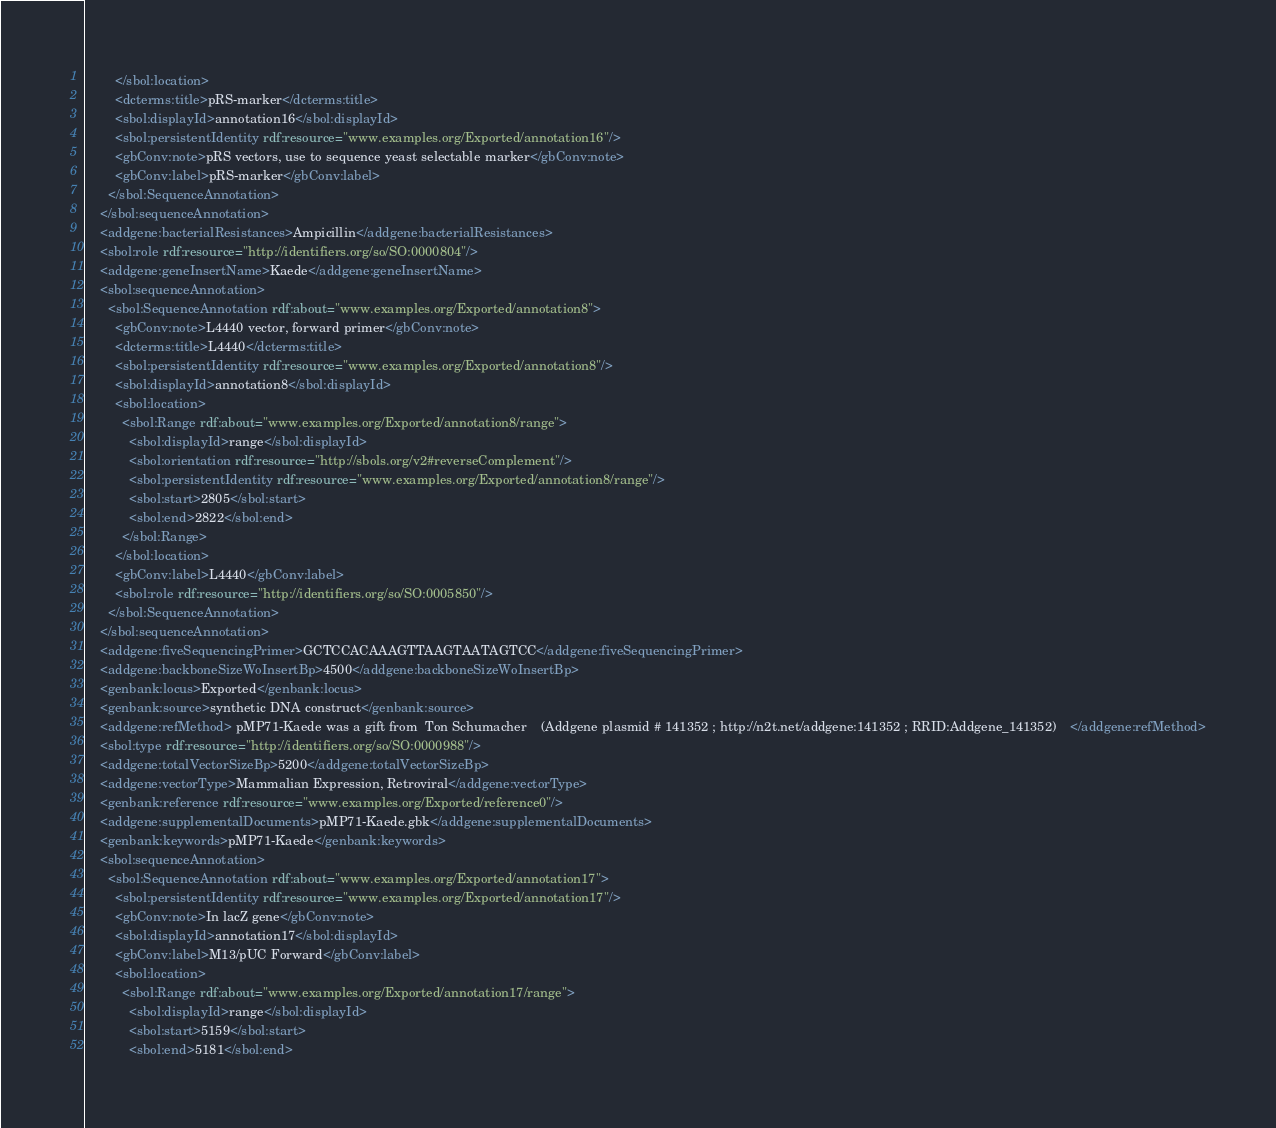<code> <loc_0><loc_0><loc_500><loc_500><_XML_>        </sbol:location>
        <dcterms:title>pRS-marker</dcterms:title>
        <sbol:displayId>annotation16</sbol:displayId>
        <sbol:persistentIdentity rdf:resource="www.examples.org/Exported/annotation16"/>
        <gbConv:note>pRS vectors, use to sequence yeast selectable marker</gbConv:note>
        <gbConv:label>pRS-marker</gbConv:label>
      </sbol:SequenceAnnotation>
    </sbol:sequenceAnnotation>
    <addgene:bacterialResistances>Ampicillin</addgene:bacterialResistances>
    <sbol:role rdf:resource="http://identifiers.org/so/SO:0000804"/>
    <addgene:geneInsertName>Kaede</addgene:geneInsertName>
    <sbol:sequenceAnnotation>
      <sbol:SequenceAnnotation rdf:about="www.examples.org/Exported/annotation8">
        <gbConv:note>L4440 vector, forward primer</gbConv:note>
        <dcterms:title>L4440</dcterms:title>
        <sbol:persistentIdentity rdf:resource="www.examples.org/Exported/annotation8"/>
        <sbol:displayId>annotation8</sbol:displayId>
        <sbol:location>
          <sbol:Range rdf:about="www.examples.org/Exported/annotation8/range">
            <sbol:displayId>range</sbol:displayId>
            <sbol:orientation rdf:resource="http://sbols.org/v2#reverseComplement"/>
            <sbol:persistentIdentity rdf:resource="www.examples.org/Exported/annotation8/range"/>
            <sbol:start>2805</sbol:start>
            <sbol:end>2822</sbol:end>
          </sbol:Range>
        </sbol:location>
        <gbConv:label>L4440</gbConv:label>
        <sbol:role rdf:resource="http://identifiers.org/so/SO:0005850"/>
      </sbol:SequenceAnnotation>
    </sbol:sequenceAnnotation>
    <addgene:fiveSequencingPrimer>GCTCCACAAAGTTAAGTAATAGTCC</addgene:fiveSequencingPrimer>
    <addgene:backboneSizeWoInsertBp>4500</addgene:backboneSizeWoInsertBp>
    <genbank:locus>Exported</genbank:locus>
    <genbank:source>synthetic DNA construct</genbank:source>
    <addgene:refMethod> pMP71-Kaede was a gift from  Ton Schumacher    (Addgene plasmid # 141352 ; http://n2t.net/addgene:141352 ; RRID:Addgene_141352)    </addgene:refMethod>
    <sbol:type rdf:resource="http://identifiers.org/so/SO:0000988"/>
    <addgene:totalVectorSizeBp>5200</addgene:totalVectorSizeBp>
    <addgene:vectorType>Mammalian Expression, Retroviral</addgene:vectorType>
    <genbank:reference rdf:resource="www.examples.org/Exported/reference0"/>
    <addgene:supplementalDocuments>pMP71-Kaede.gbk</addgene:supplementalDocuments>
    <genbank:keywords>pMP71-Kaede</genbank:keywords>
    <sbol:sequenceAnnotation>
      <sbol:SequenceAnnotation rdf:about="www.examples.org/Exported/annotation17">
        <sbol:persistentIdentity rdf:resource="www.examples.org/Exported/annotation17"/>
        <gbConv:note>In lacZ gene</gbConv:note>
        <sbol:displayId>annotation17</sbol:displayId>
        <gbConv:label>M13/pUC Forward</gbConv:label>
        <sbol:location>
          <sbol:Range rdf:about="www.examples.org/Exported/annotation17/range">
            <sbol:displayId>range</sbol:displayId>
            <sbol:start>5159</sbol:start>
            <sbol:end>5181</sbol:end></code> 